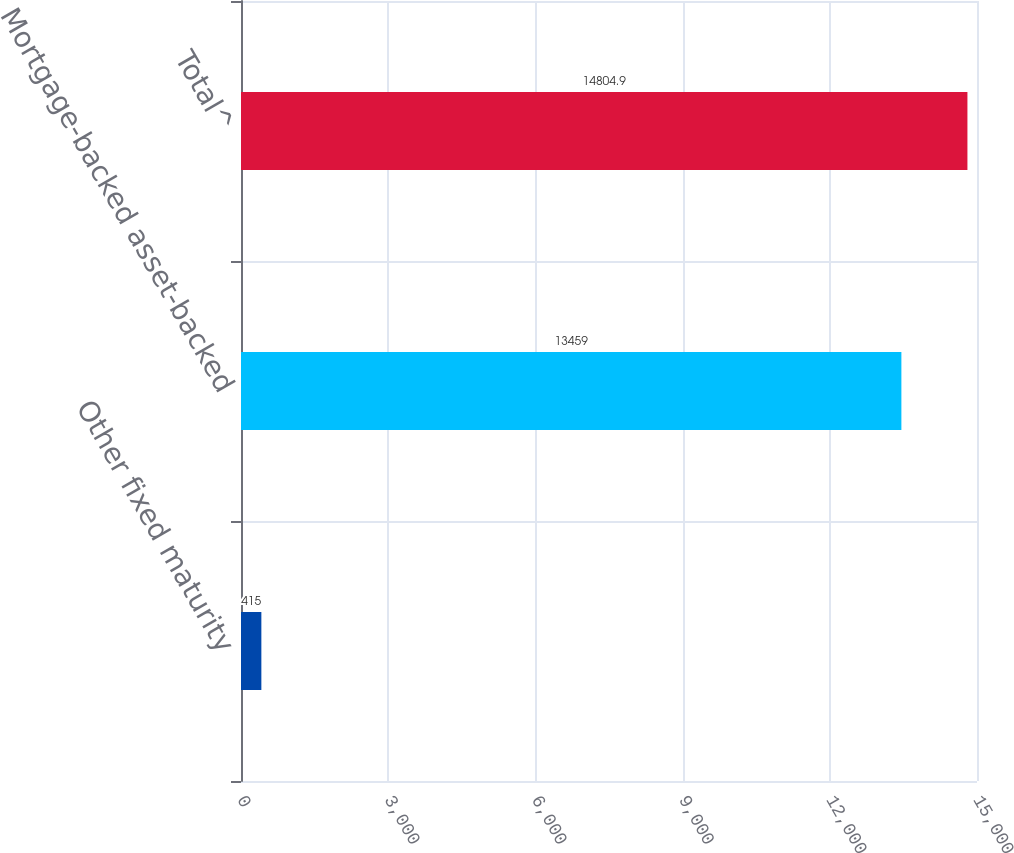Convert chart to OTSL. <chart><loc_0><loc_0><loc_500><loc_500><bar_chart><fcel>Other fixed maturity<fcel>Mortgage-backed asset-backed<fcel>Total^<nl><fcel>415<fcel>13459<fcel>14804.9<nl></chart> 